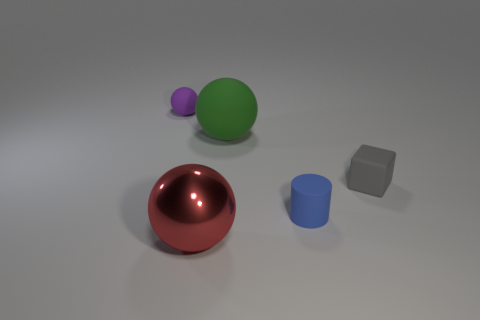There is a gray thing that is the same size as the blue rubber cylinder; what is its material? rubber 